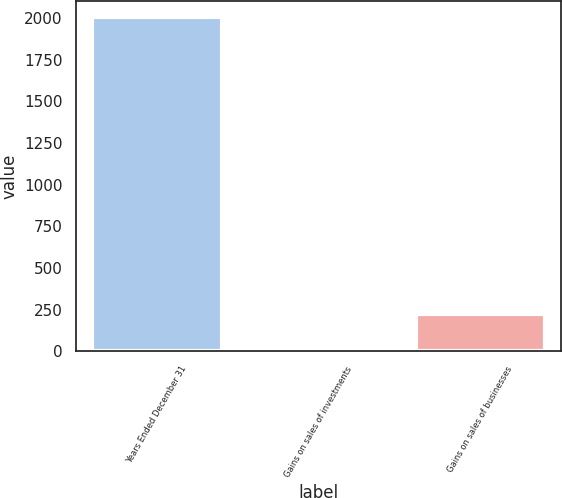Convert chart. <chart><loc_0><loc_0><loc_500><loc_500><bar_chart><fcel>Years Ended December 31<fcel>Gains on sales of investments<fcel>Gains on sales of businesses<nl><fcel>2002<fcel>27<fcel>224.5<nl></chart> 